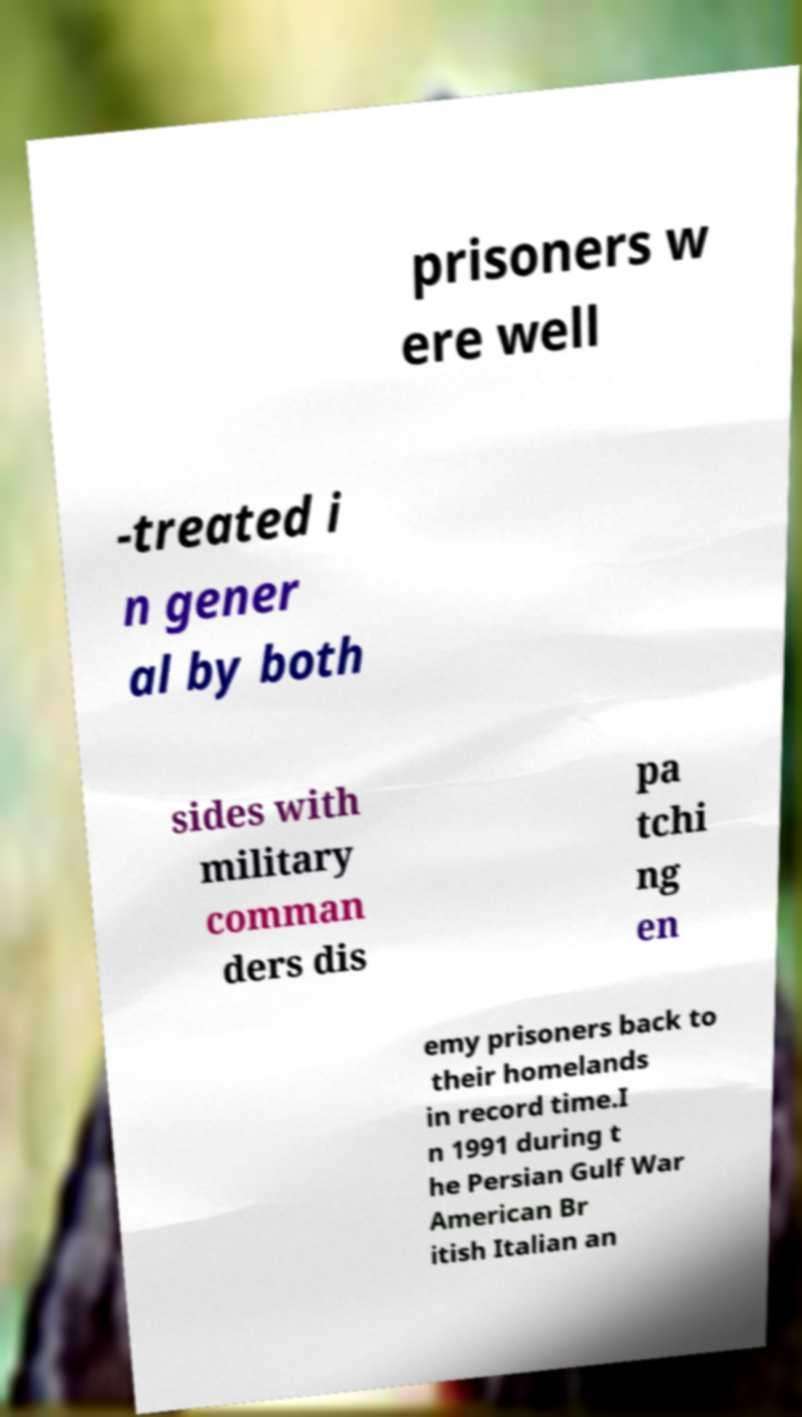There's text embedded in this image that I need extracted. Can you transcribe it verbatim? prisoners w ere well -treated i n gener al by both sides with military comman ders dis pa tchi ng en emy prisoners back to their homelands in record time.I n 1991 during t he Persian Gulf War American Br itish Italian an 